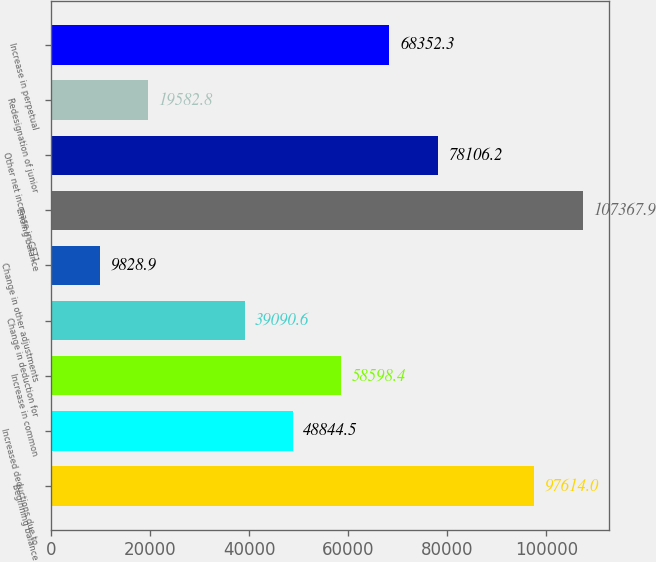Convert chart. <chart><loc_0><loc_0><loc_500><loc_500><bar_chart><fcel>Beginning balance<fcel>Increased deductions due to<fcel>Increase in common<fcel>Change in deduction for<fcel>Change in other adjustments<fcel>Ending balance<fcel>Other net increase in CET1<fcel>Redesignation of junior<fcel>Increase in perpetual<nl><fcel>97614<fcel>48844.5<fcel>58598.4<fcel>39090.6<fcel>9828.9<fcel>107368<fcel>78106.2<fcel>19582.8<fcel>68352.3<nl></chart> 